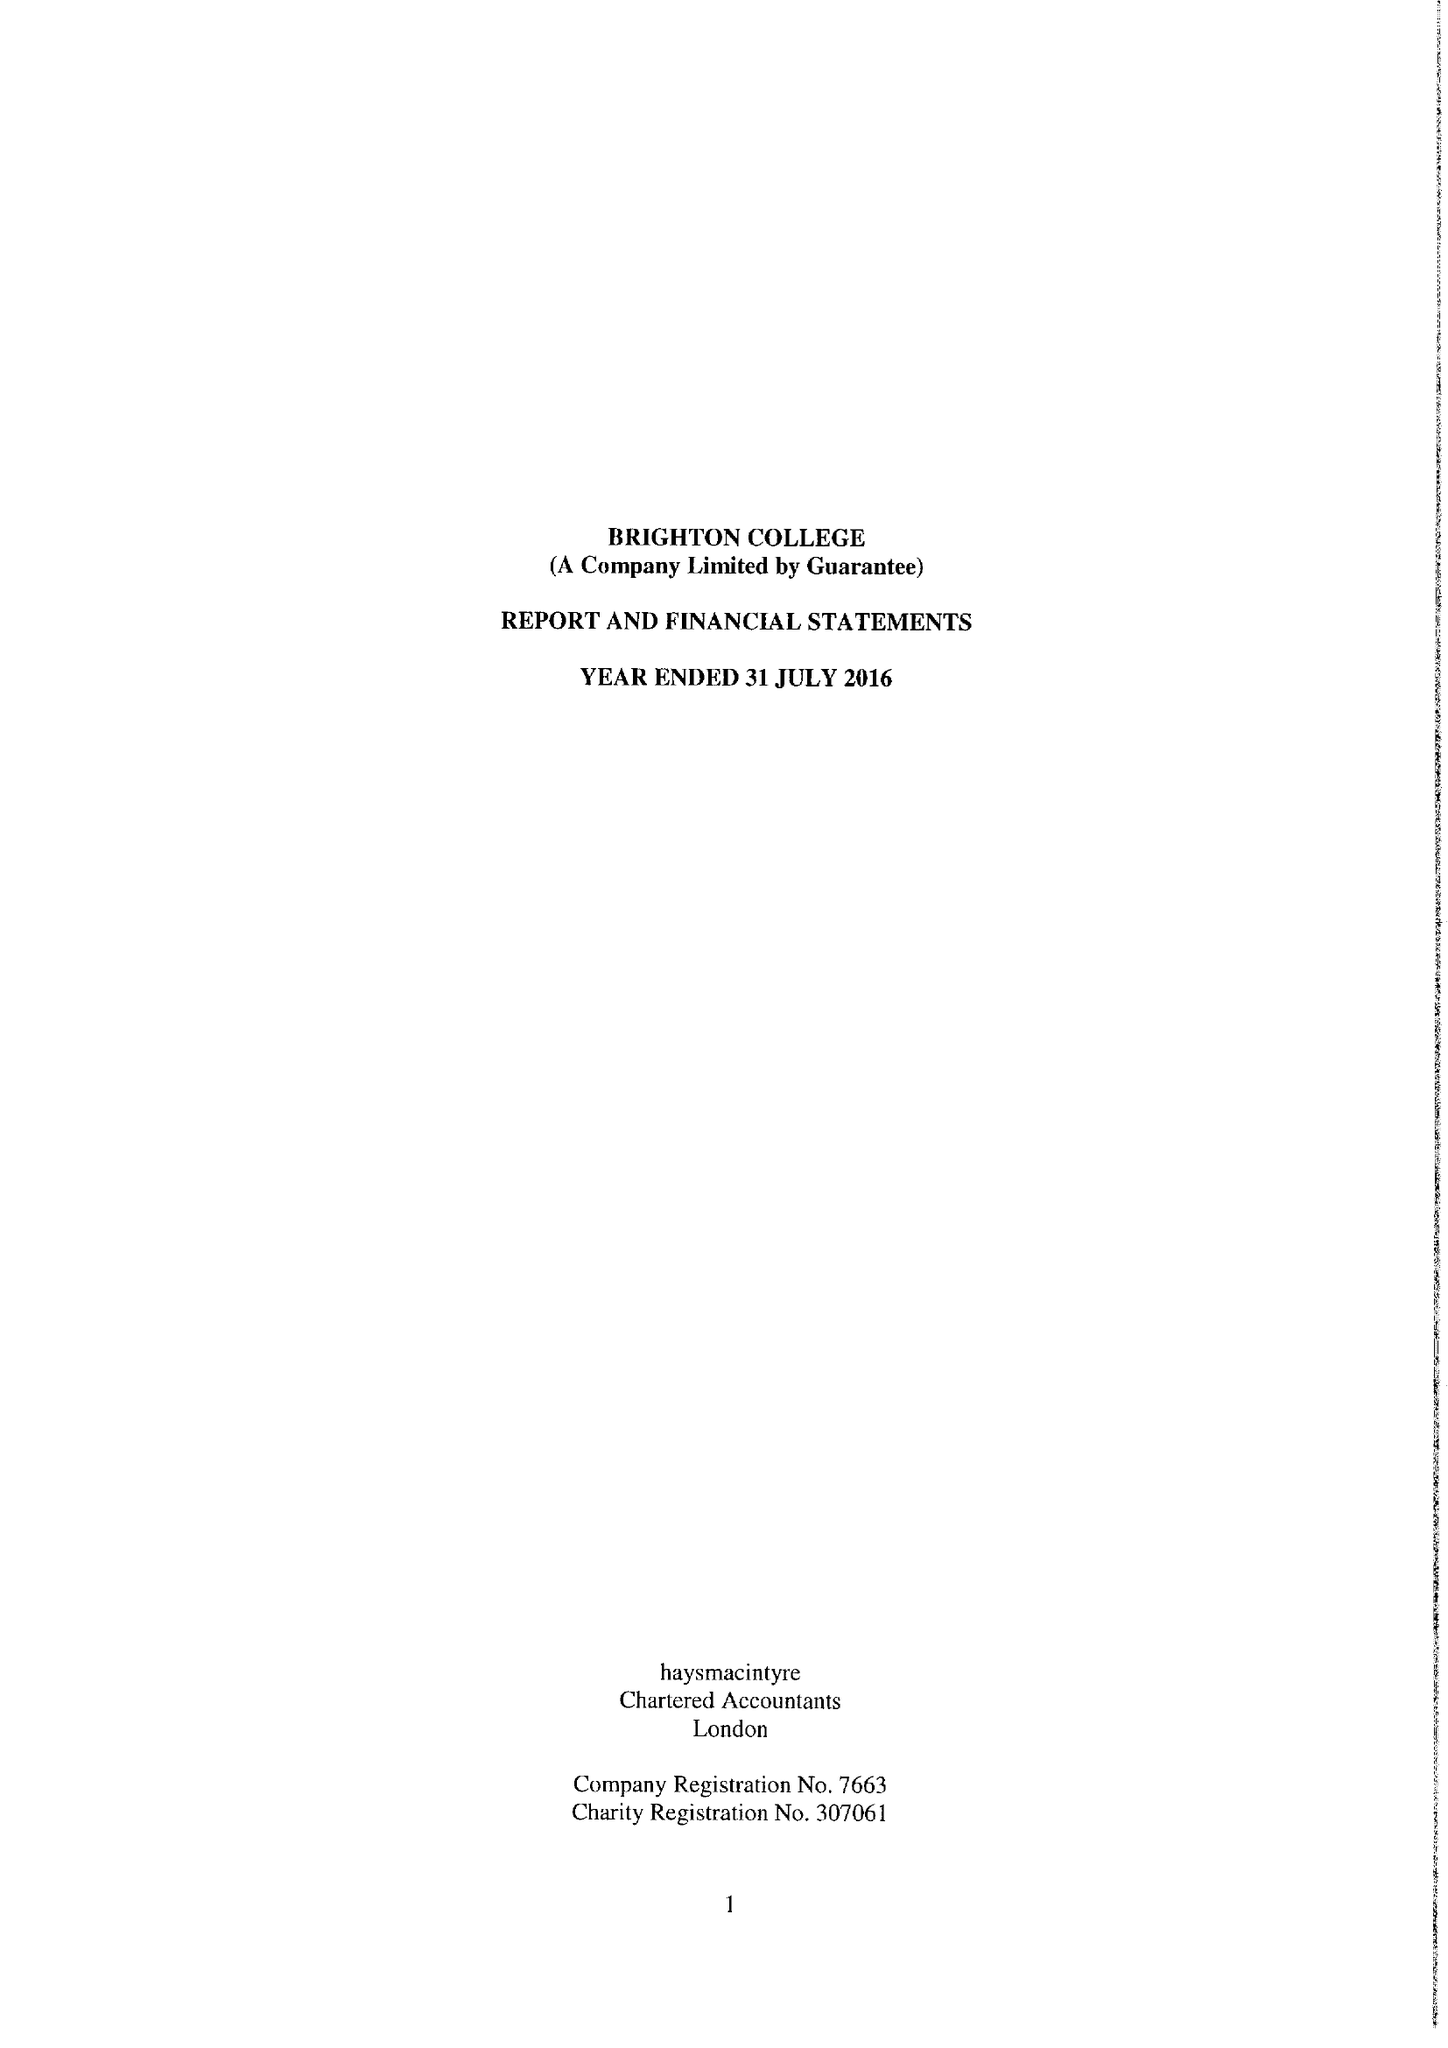What is the value for the spending_annually_in_british_pounds?
Answer the question using a single word or phrase. 36514866.00 